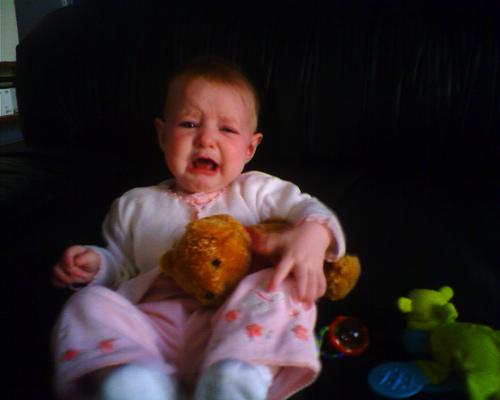What color are the girl's socks?
Be succinct. White. How many babies are in the picture?
Short answer required. 1. Is this baby happy?
Write a very short answer. No. Is the bear wearing an infant shirt?
Write a very short answer. No. What cartoon characters are on the high chair cover?
Answer briefly. None. How many children are in the picture?
Keep it brief. 1. What is making the baby cry?
Keep it brief. Teddy bear. Is the girl happy?
Be succinct. No. What is the toy sitting on?
Answer briefly. Baby. Does this little girl look happy?
Be succinct. No. What is the little girl sitting in?
Give a very brief answer. Couch. What color is her dress?
Keep it brief. Pink. What is the baby doing?
Short answer required. Crying. 